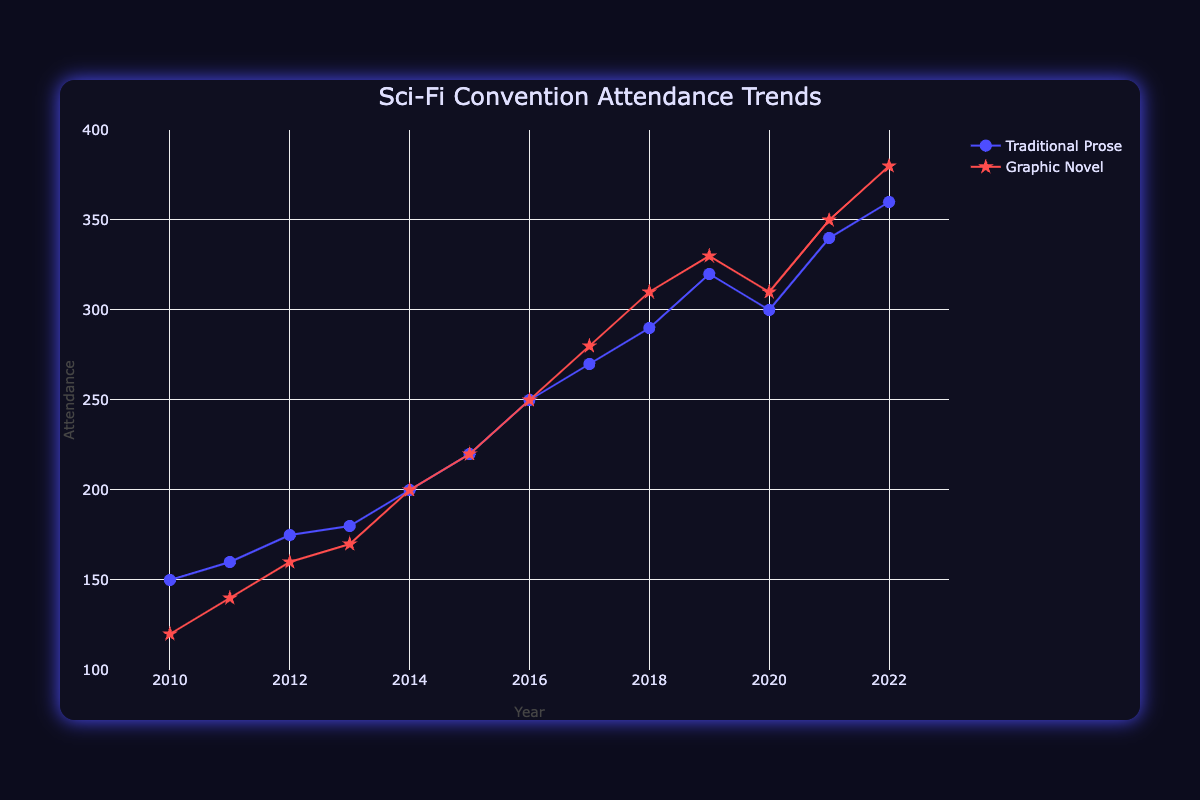What's the title of the chart? The title of the chart is displayed at the top and reads, "Sci-Fi Convention Attendance Trends".
Answer: Sci-Fi Convention Attendance Trends What is the attendance in 2018 for graphic novel-focused panels? To find the attendance for 2018, refer to the point on the red line (graphic novel) at the year 2018. The y-axis value for this point is 310.
Answer: 310 How does the attendance trend for graphic novel-focused panels compare to traditional prose-focused panels over the years? By observing the trend lines, both the traditional prose (blue) and graphic novel (red) have an upward trend, but the red line shows a slightly steeper incline, suggesting a sharper increase in attendance over the years for graphic novels.
Answer: Graphic novel-focused panels have a sharper increase What was the general trend in attendance from 2019 to 2020 for both panel types? Both trend lines show a decline in attendance from 2019 to 2020, visible as a drop at the 2020 data point for both traditional prose and graphic novel.
Answer: Decline Was there an increase in attendance for traditional prose-focused panels from 2021 to 2022? To determine this, compare the attendance in 2021 (340) to the attendance in 2022 (360). Since 360 is greater than 340, there was an increase.
Answer: Yes Which year had the highest attendance for graphic novel-focused panels? Looking at the peak of the red trend line, the year with the highest attendance is 2022 with 380 attendees.
Answer: 2022 What is the difference in attendance between traditional prose and graphic novel-focused panels in the year 2022? For 2022, traditional prose attendance is 360 and graphic novel attendance is 380. The difference is 380 - 360 = 20.
Answer: 20 On average, which type of panel had a steeper increase in attendance over the years? By comparing the slopes of both lines, the red line (graphic novel) appears steeper than the blue line (traditional prose), indicating a steeper average increase.
Answer: Graphic novel-focused panels What is the range of attendance for traditional prose-focused panels from 2010 to 2022? The minimum attendance for traditional prose is 150 (in 2010) and the maximum is 360 (in 2022). The range is 360 - 150 = 210.
Answer: 210 